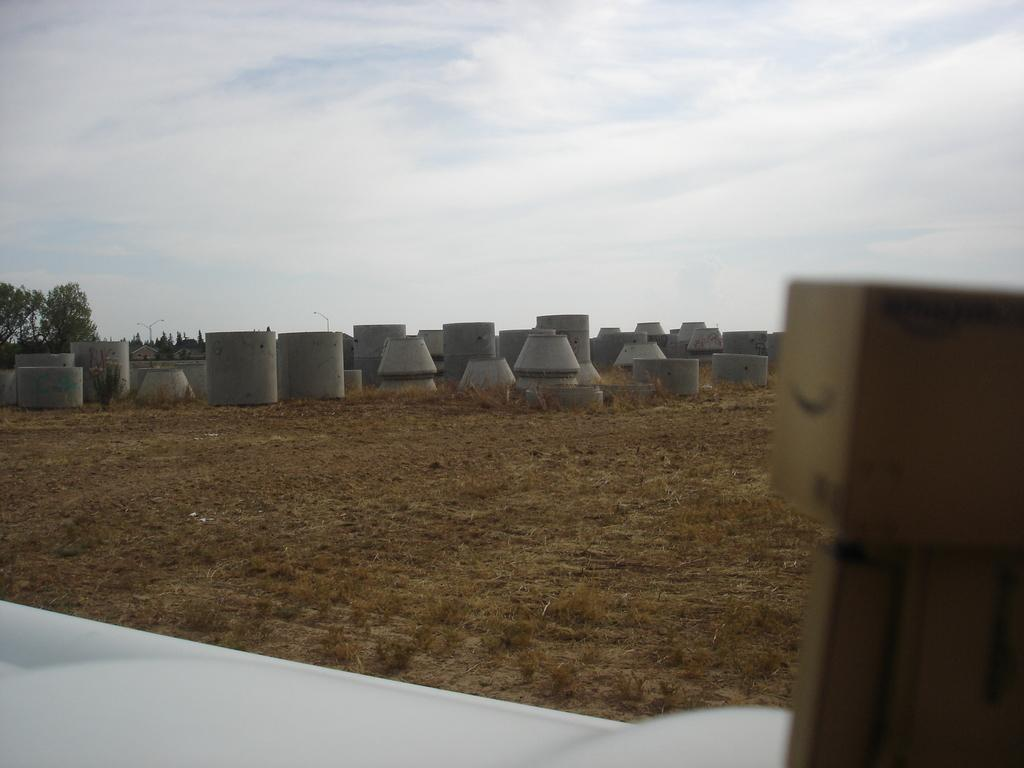What type of vegetation is present in the image? There is dry grass in the image. What other natural elements can be seen in the image? There are trees in the image. What color is the object mentioned in the facts? The object is white in color. How would you describe the weather based on the image? The sky is cloudy in the image, suggesting overcast or potentially rainy weather. What type of man-made structures are present in the image? There are objects made up of cement in the image. Can you see a leg wearing a shoe in the image? There is no leg or shoe present in the image. What type of pencil can be seen in the image? There is no pencil present in the image. 